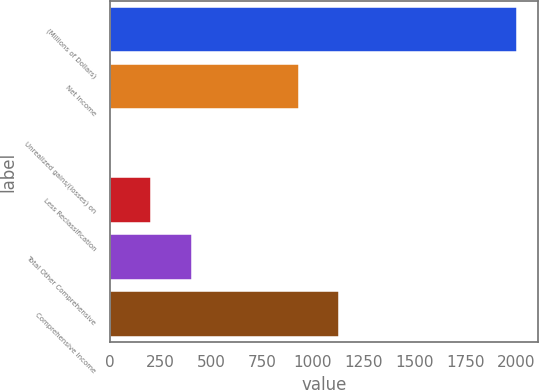<chart> <loc_0><loc_0><loc_500><loc_500><bar_chart><fcel>(Millions of Dollars)<fcel>Net Income<fcel>Unrealized gains/(losses) on<fcel>Less Reclassification<fcel>Total Other Comprehensive<fcel>Comprehensive Income<nl><fcel>2007<fcel>929<fcel>3<fcel>203.4<fcel>403.8<fcel>1129.4<nl></chart> 